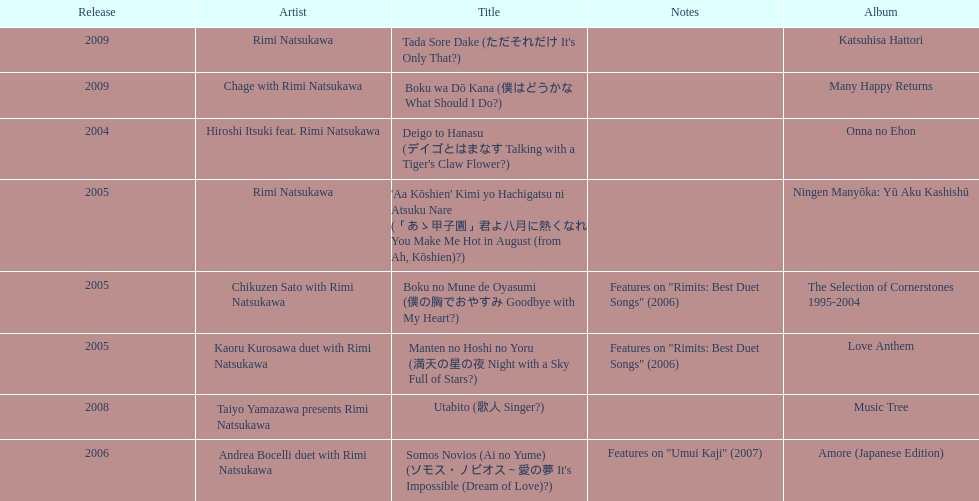Can you parse all the data within this table? {'header': ['Release', 'Artist', 'Title', 'Notes', 'Album'], 'rows': [['2009', 'Rimi Natsukawa', "Tada Sore Dake (ただそれだけ It's Only That?)", '', 'Katsuhisa Hattori'], ['2009', 'Chage with Rimi Natsukawa', 'Boku wa Dō Kana (僕はどうかな What Should I Do?)', '', 'Many Happy Returns'], ['2004', 'Hiroshi Itsuki feat. Rimi Natsukawa', "Deigo to Hanasu (デイゴとはまなす Talking with a Tiger's Claw Flower?)", '', 'Onna no Ehon'], ['2005', 'Rimi Natsukawa', "'Aa Kōshien' Kimi yo Hachigatsu ni Atsuku Nare (「あゝ甲子園」君よ八月に熱くなれ You Make Me Hot in August (from Ah, Kōshien)?)", '', 'Ningen Manyōka: Yū Aku Kashishū'], ['2005', 'Chikuzen Sato with Rimi Natsukawa', 'Boku no Mune de Oyasumi (僕の胸でおやすみ Goodbye with My Heart?)', 'Features on "Rimits: Best Duet Songs" (2006)', 'The Selection of Cornerstones 1995-2004'], ['2005', 'Kaoru Kurosawa duet with Rimi Natsukawa', 'Manten no Hoshi no Yoru (満天の星の夜 Night with a Sky Full of Stars?)', 'Features on "Rimits: Best Duet Songs" (2006)', 'Love Anthem'], ['2008', 'Taiyo Yamazawa presents Rimi Natsukawa', 'Utabito (歌人 Singer?)', '', 'Music Tree'], ['2006', 'Andrea Bocelli duet with Rimi Natsukawa', "Somos Novios (Ai no Yume) (ソモス・ノビオス～愛の夢 It's Impossible (Dream of Love)?)", 'Features on "Umui Kaji" (2007)', 'Amore (Japanese Edition)']]} How many titles have only one artist? 2. 